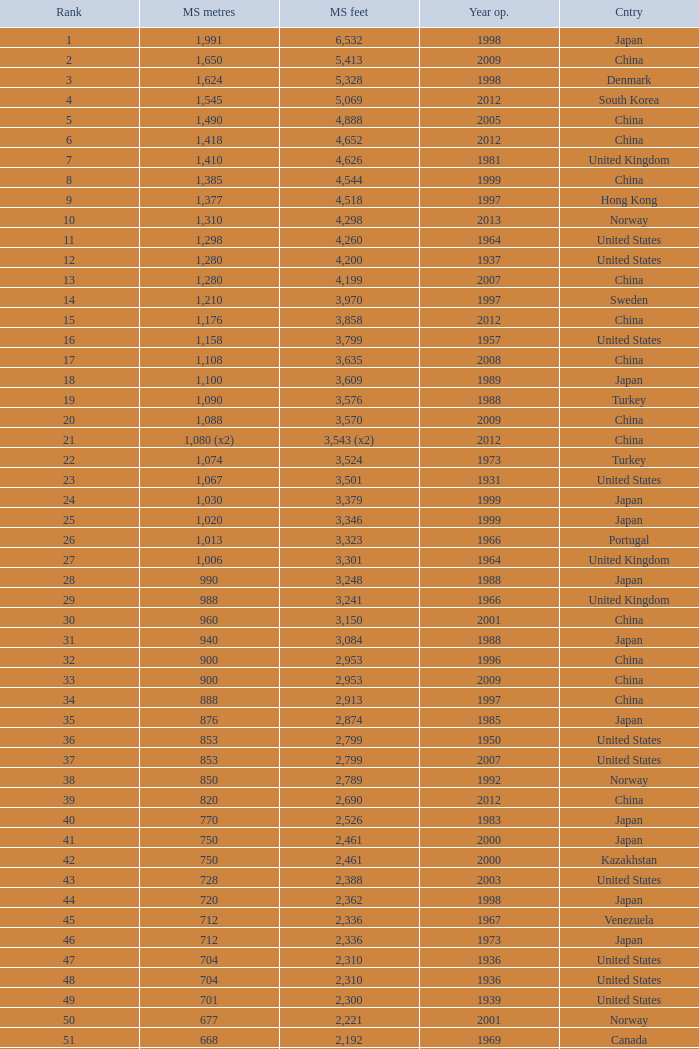What was the first year in south korea when a main span of 1,640 feet was recorded? 2002.0. 